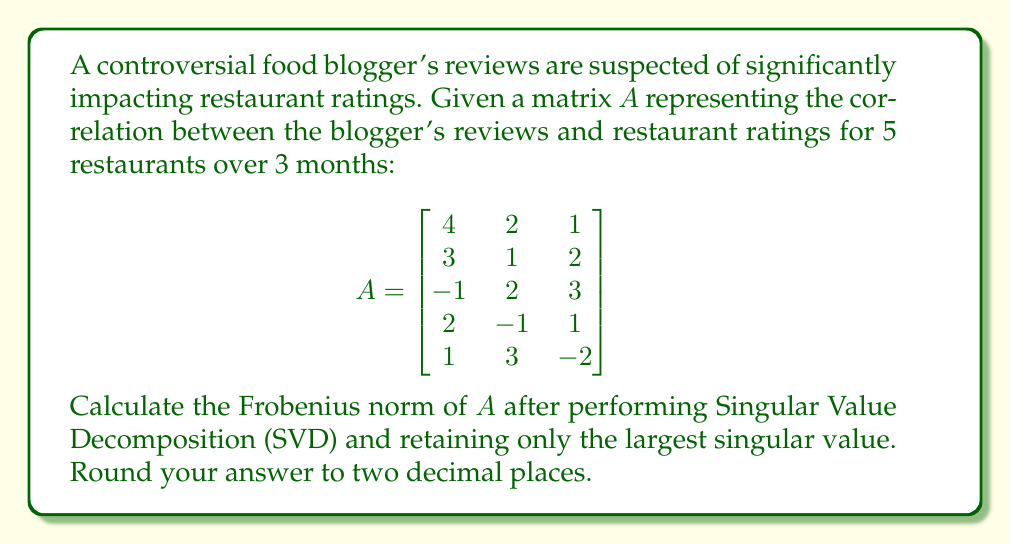Teach me how to tackle this problem. 1) First, we need to perform Singular Value Decomposition on matrix $A$. The SVD of $A$ is given by $A = U\Sigma V^T$, where $U$ and $V$ are orthogonal matrices and $\Sigma$ is a diagonal matrix containing the singular values.

2) Calculate the singular values of $A$. The singular values are the square roots of the eigenvalues of $A^TA$ or $AA^T$. Using a computer algebra system, we find the singular values:

   $\sigma_1 \approx 6.3246$
   $\sigma_2 \approx 3.4641$
   $\sigma_3 \approx 1.8817$

3) Retain only the largest singular value $\sigma_1 \approx 6.3246$. The new $\Sigma$ matrix becomes:

   $$\Sigma' = \begin{bmatrix}
   6.3246 & 0 & 0 \\
   0 & 0 & 0 \\
   0 & 0 & 0 \\
   0 & 0 & 0 \\
   0 & 0 & 0
   \end{bmatrix}$$

4) Reconstruct the matrix $A'$ using only the largest singular value:

   $A' = U\Sigma'V^T$

5) The Frobenius norm of a matrix is the square root of the sum of the squares of its elements. For a matrix reconstructed from SVD using only k singular values, the Frobenius norm is equal to the square root of the sum of the squares of those k singular values.

6) In this case, we're only using the largest singular value, so the Frobenius norm is simply:

   $\|A'\|_F = \sqrt{\sigma_1^2} = \sigma_1 \approx 6.3246$

7) Rounding to two decimal places, we get 6.32.
Answer: 6.32 